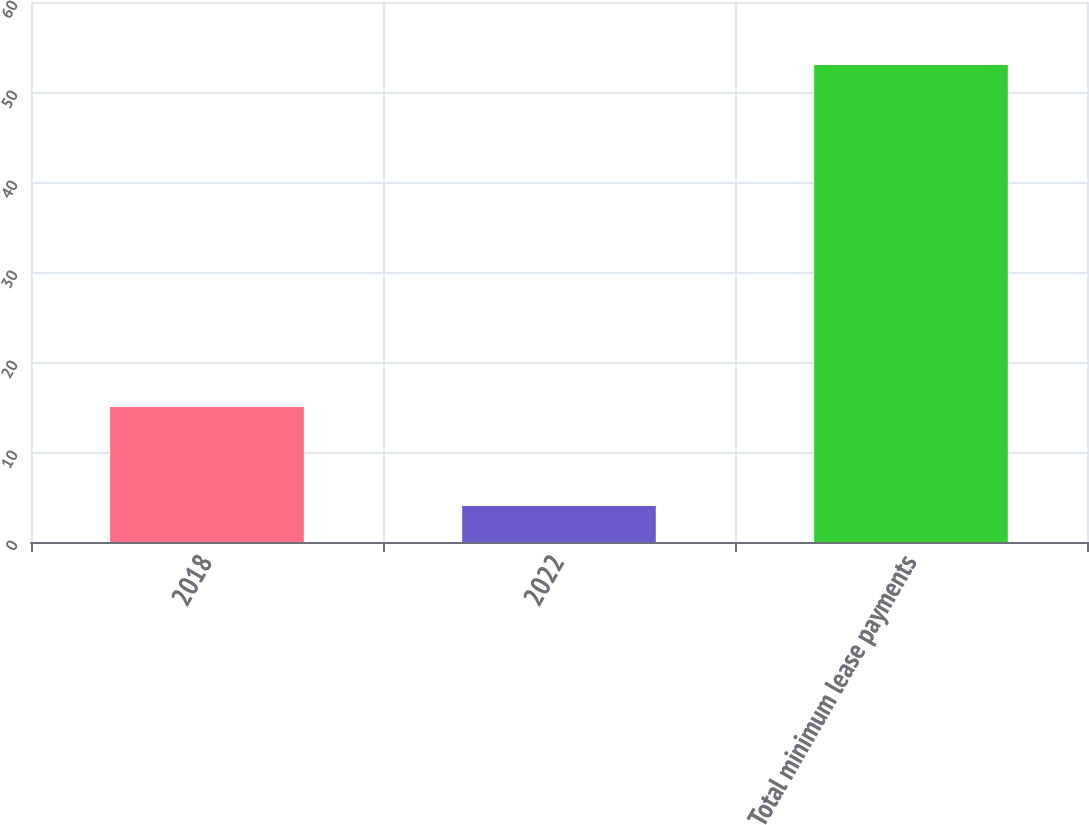<chart> <loc_0><loc_0><loc_500><loc_500><bar_chart><fcel>2018<fcel>2022<fcel>Total minimum lease payments<nl><fcel>15<fcel>4<fcel>53<nl></chart> 